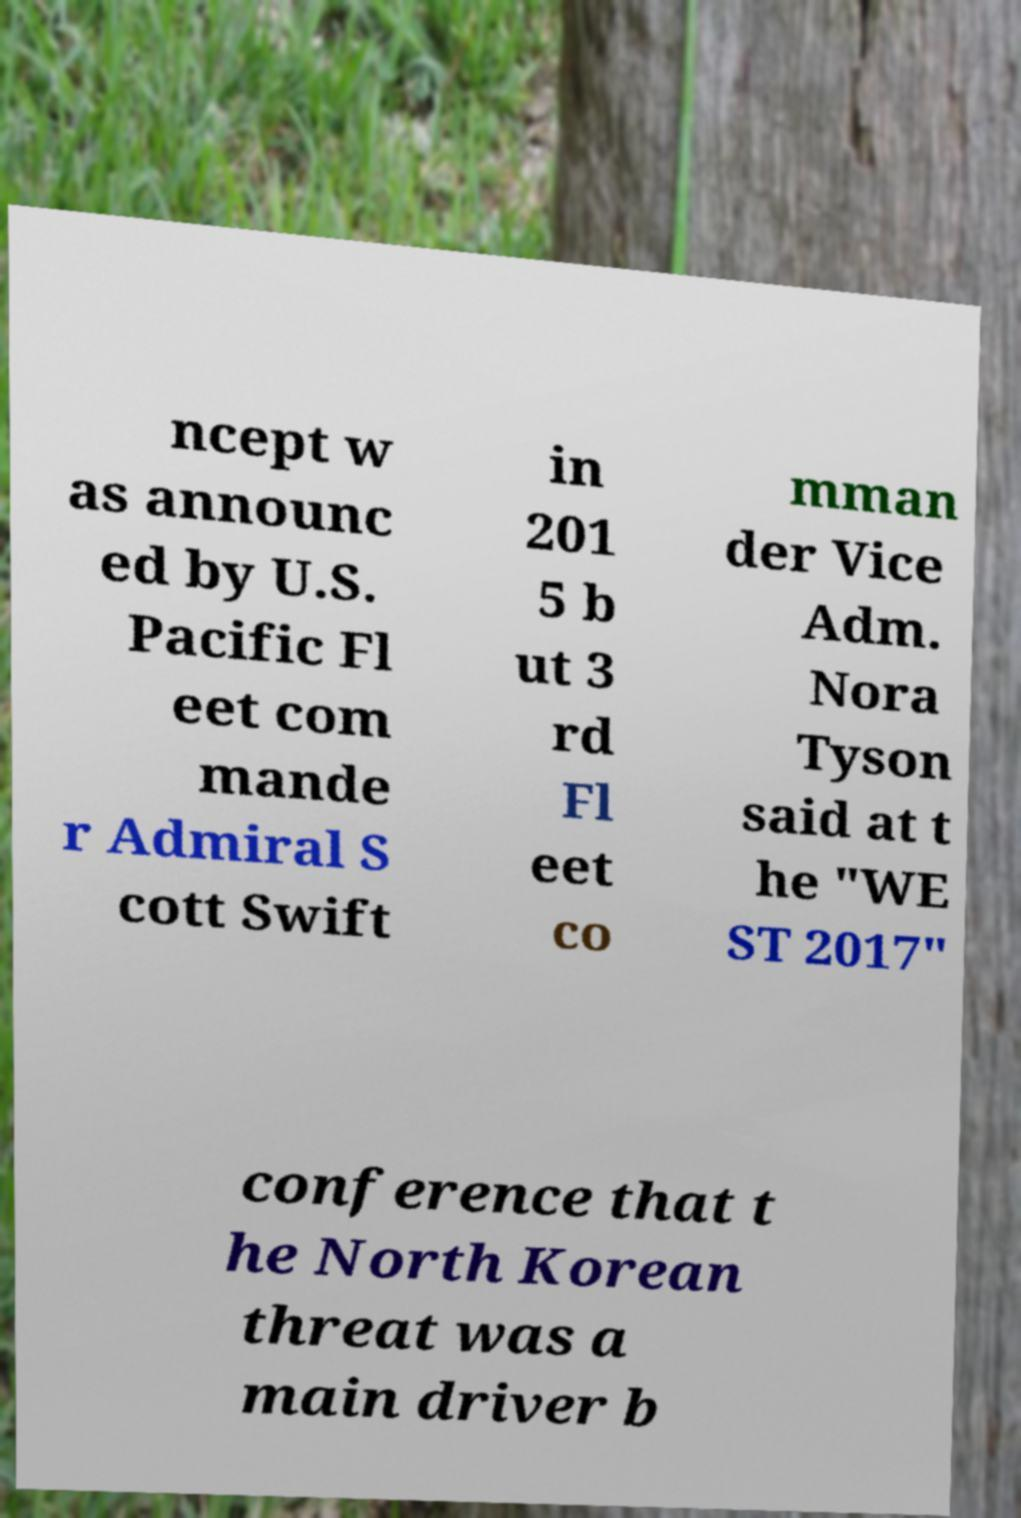There's text embedded in this image that I need extracted. Can you transcribe it verbatim? ncept w as announc ed by U.S. Pacific Fl eet com mande r Admiral S cott Swift in 201 5 b ut 3 rd Fl eet co mman der Vice Adm. Nora Tyson said at t he "WE ST 2017" conference that t he North Korean threat was a main driver b 